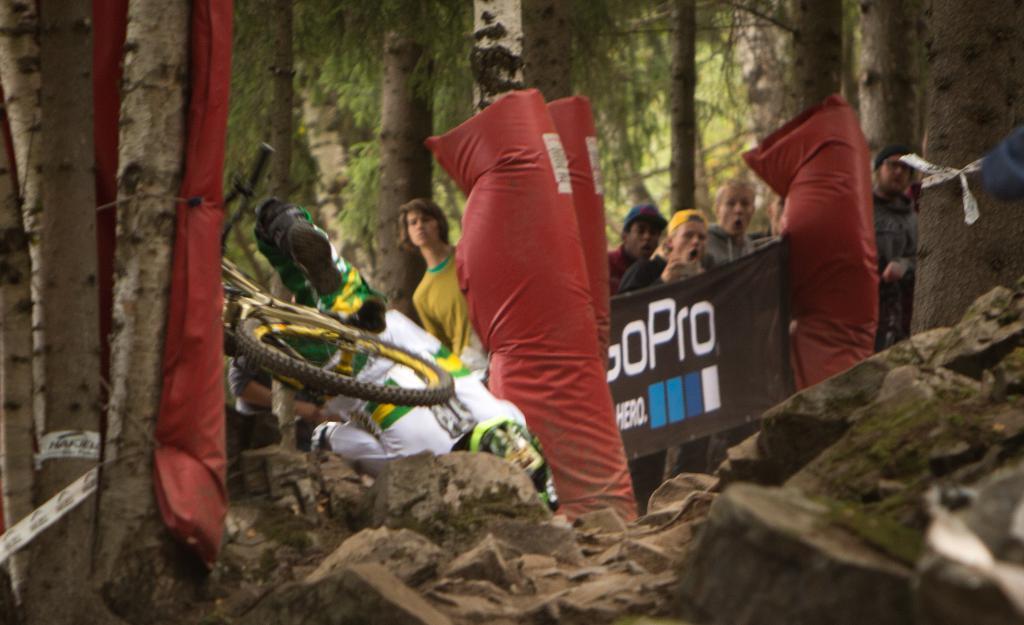How would you summarize this image in a sentence or two? There are stones and trunks in the foreground area of the image, there is a person who fall down on the left side of the image. There is a poster, inflatable balloons, people and tree in the background area. 